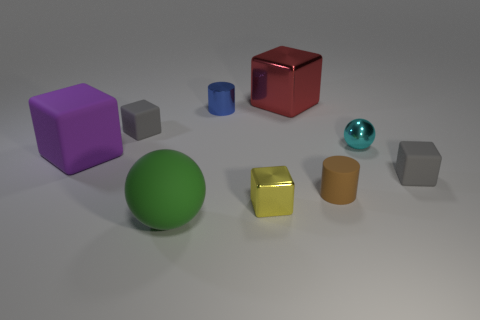What number of large blocks are behind the small cyan sphere?
Your answer should be compact. 1. Is the number of brown rubber cylinders behind the matte cylinder less than the number of brown matte cylinders that are left of the large purple object?
Make the answer very short. No. There is a tiny shiny thing that is behind the gray thing to the left of the tiny blue cylinder to the right of the rubber sphere; what is its shape?
Your answer should be very brief. Cylinder. What is the shape of the tiny object that is behind the tiny sphere and to the right of the green sphere?
Offer a terse response. Cylinder. Is there a small red cube that has the same material as the tiny brown cylinder?
Your response must be concise. No. What is the color of the large block that is to the right of the yellow thing?
Keep it short and to the point. Red. Does the large green thing have the same shape as the gray object right of the small cyan thing?
Offer a terse response. No. Are there any matte objects of the same color as the tiny metal sphere?
Provide a short and direct response. No. What is the size of the yellow object that is the same material as the blue cylinder?
Offer a very short reply. Small. Does the tiny metal sphere have the same color as the matte cylinder?
Make the answer very short. No. 